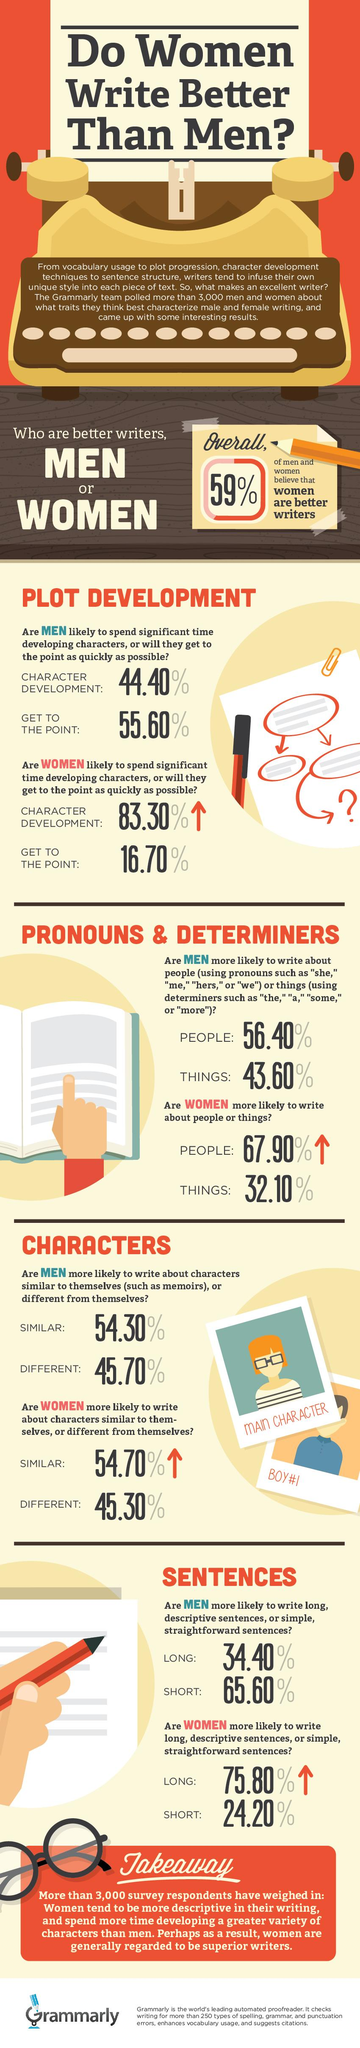Give some essential details in this illustration. Women are more likely to spend more time developing characters than men. 41% of the respondents do not believe that women are better writers. According to a study, 54.30% of men are more likely to write memoirs. It is more likely for men to write about topics than women. Women are more likely to write longer and more descriptive sentences than men. 